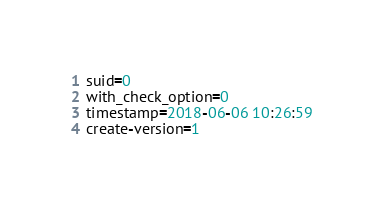<code> <loc_0><loc_0><loc_500><loc_500><_VisualBasic_>suid=0
with_check_option=0
timestamp=2018-06-06 10:26:59
create-version=1</code> 